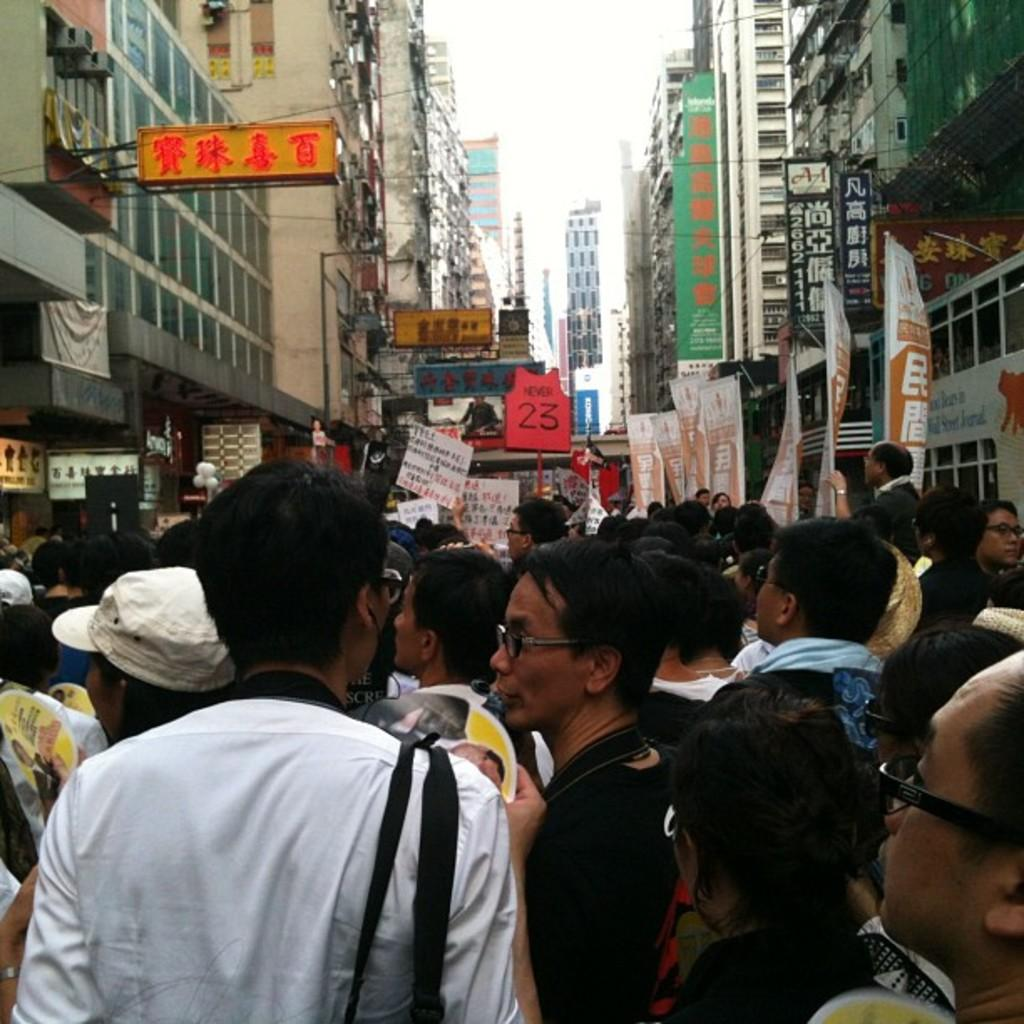What is happening in the lane in the image? There are many people walking in the lane. What can be seen on both sides of the lane? There are buildings and shops with naming boards on both sides of the lane. What is visible in the background of the image? There are buildings visible in the background. What type of faucet can be seen in the image? There is no faucet present in the image. What color is the dress worn by the person in the image? The image does not show any specific person or dress, so it cannot be determined from the image. 